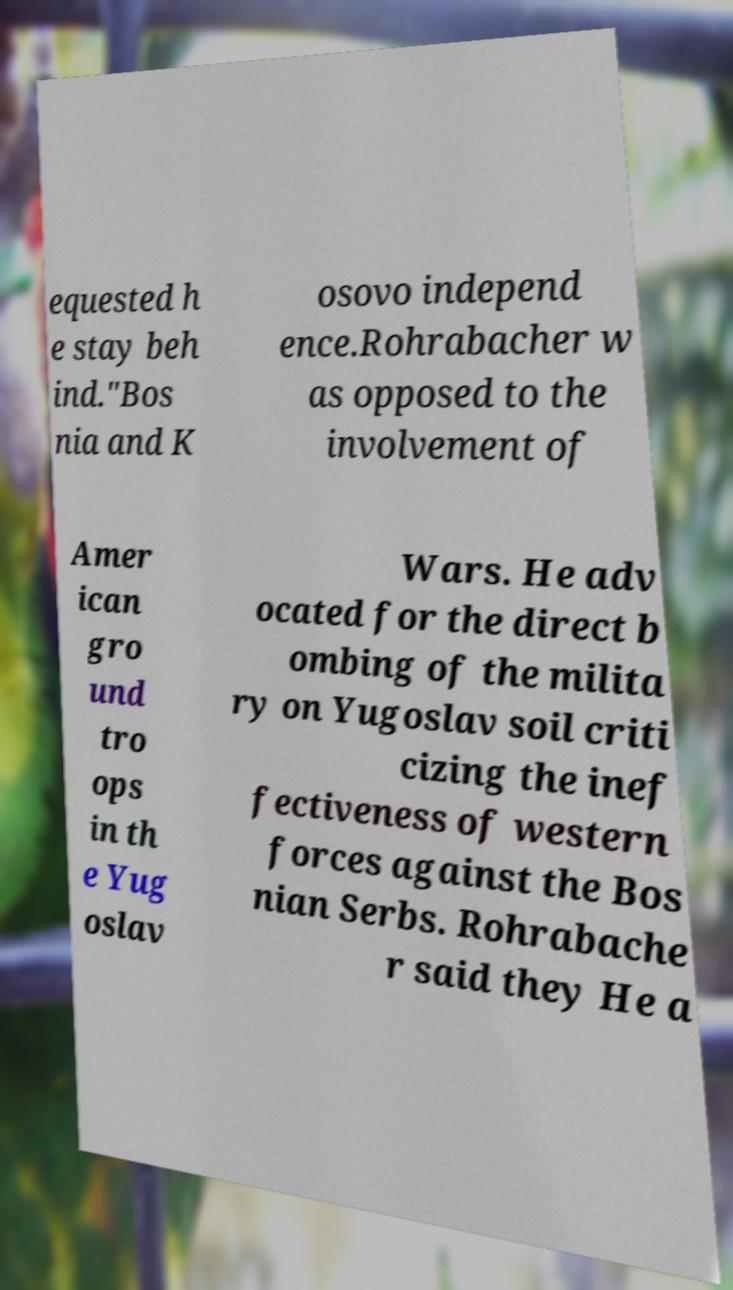Please read and relay the text visible in this image. What does it say? equested h e stay beh ind."Bos nia and K osovo independ ence.Rohrabacher w as opposed to the involvement of Amer ican gro und tro ops in th e Yug oslav Wars. He adv ocated for the direct b ombing of the milita ry on Yugoslav soil criti cizing the inef fectiveness of western forces against the Bos nian Serbs. Rohrabache r said they He a 